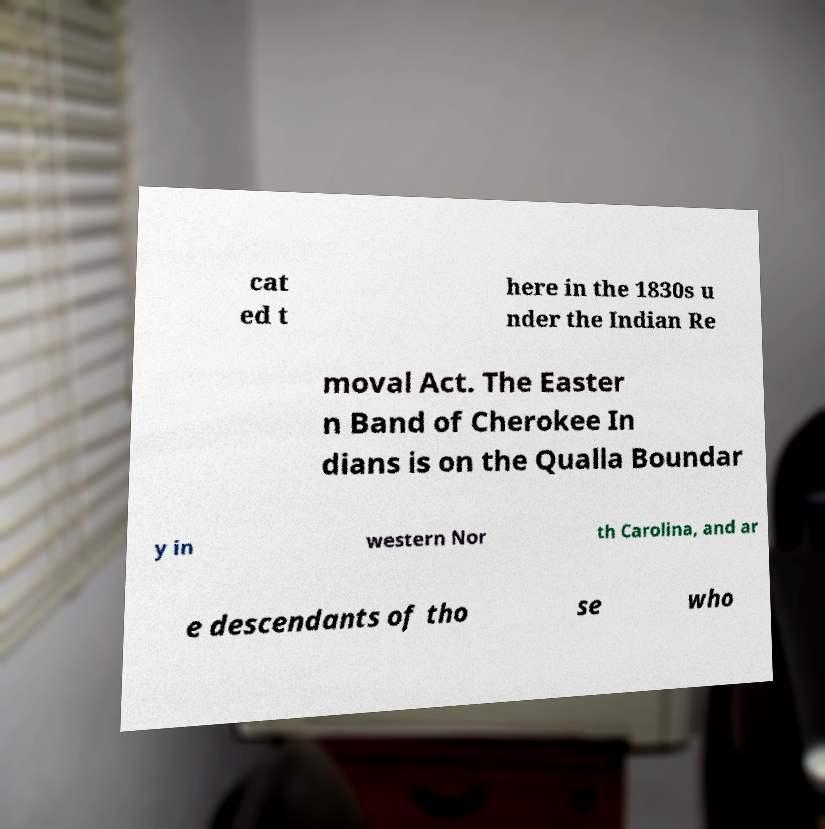Please read and relay the text visible in this image. What does it say? cat ed t here in the 1830s u nder the Indian Re moval Act. The Easter n Band of Cherokee In dians is on the Qualla Boundar y in western Nor th Carolina, and ar e descendants of tho se who 